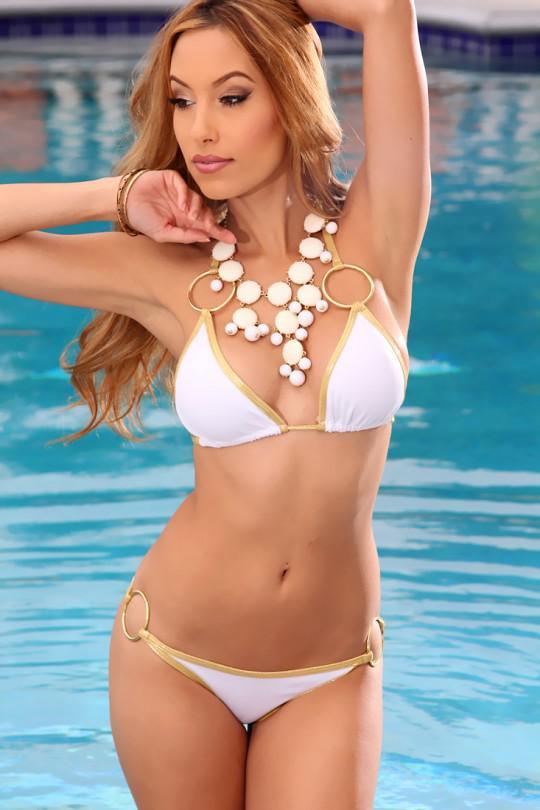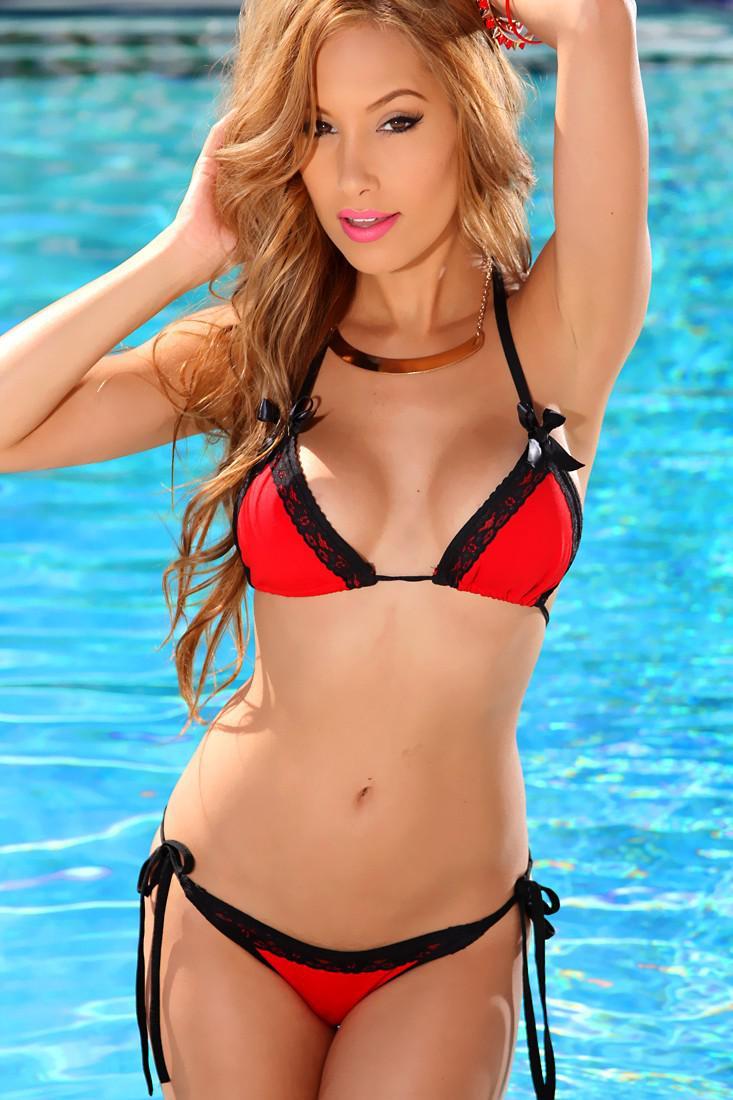The first image is the image on the left, the second image is the image on the right. Given the left and right images, does the statement "One model poses in a bikini with horizontal stripes on the top and bottom." hold true? Answer yes or no. No. The first image is the image on the left, the second image is the image on the right. Given the left and right images, does the statement "In the left image, the swimsuit top does not match the bottom." hold true? Answer yes or no. No. 